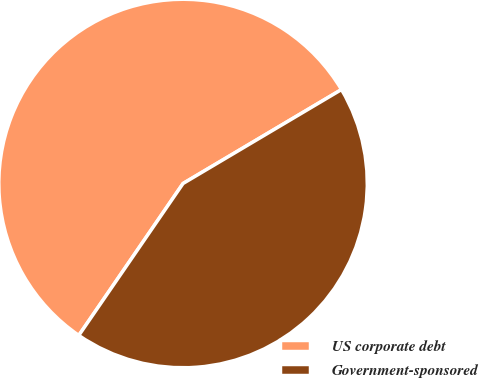Convert chart. <chart><loc_0><loc_0><loc_500><loc_500><pie_chart><fcel>US corporate debt<fcel>Government-sponsored<nl><fcel>56.91%<fcel>43.09%<nl></chart> 